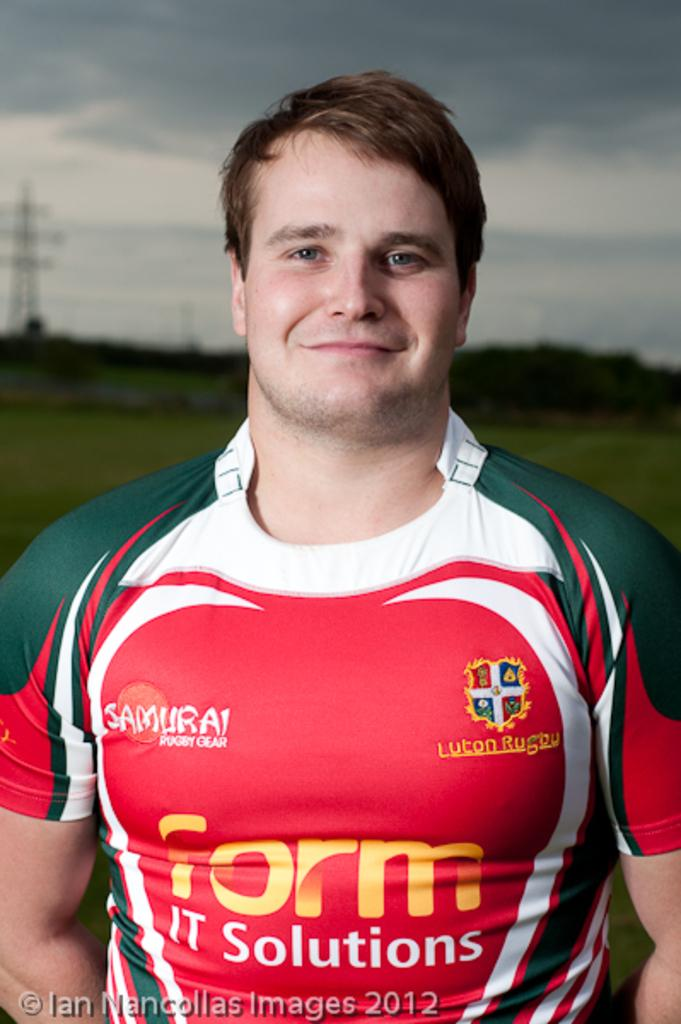<image>
Create a compact narrative representing the image presented. A man has on a green,white and red shirt with form it solutions written in front. 